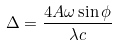Convert formula to latex. <formula><loc_0><loc_0><loc_500><loc_500>\Delta = \frac { 4 A \omega \sin \phi } { \lambda c }</formula> 